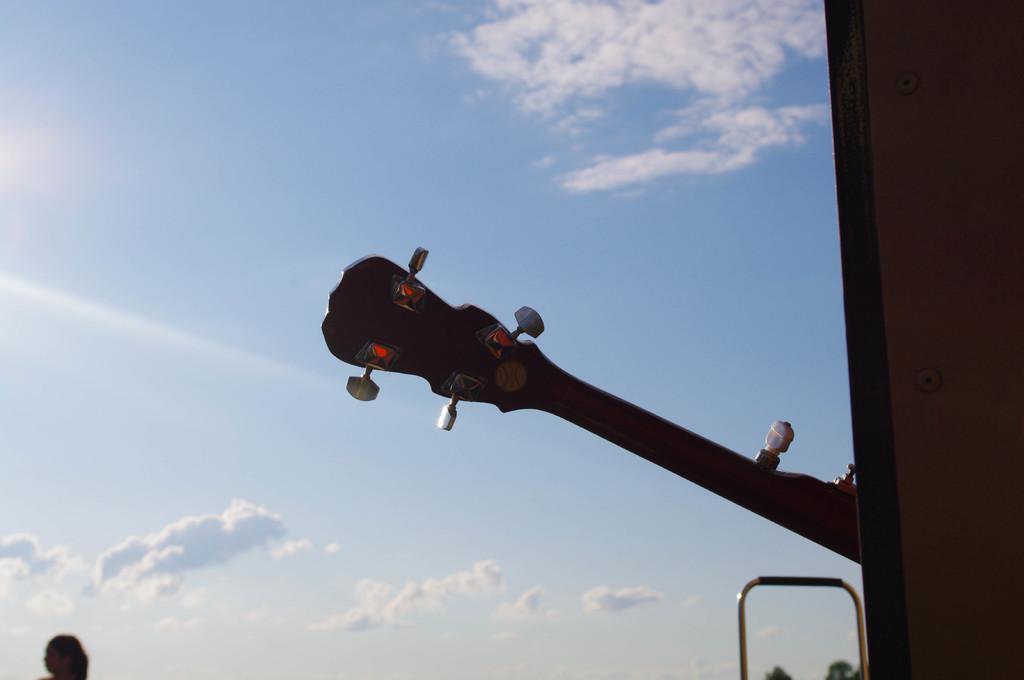Please provide a concise description of this image. In the image there is a guitar on the right side in front of the wall and in the background there are trees visible on the right side corner and a person visible on left side corner and above its sky with clouds. 